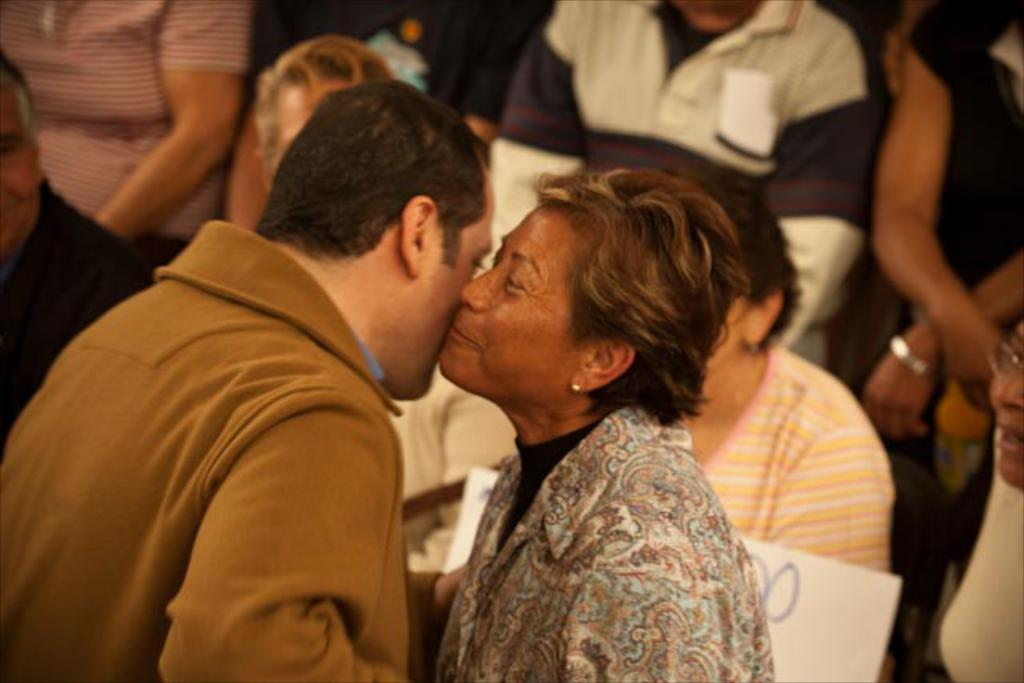What can be seen in the image? There are people in the image. Can you describe the woman in the image? There is a woman in the image, and she is smiling. How many geese are running in the image? There are no geese or running depicted in the image; it features people and a smiling woman. What type of animal is present in the image? There are no animals present in the image. 